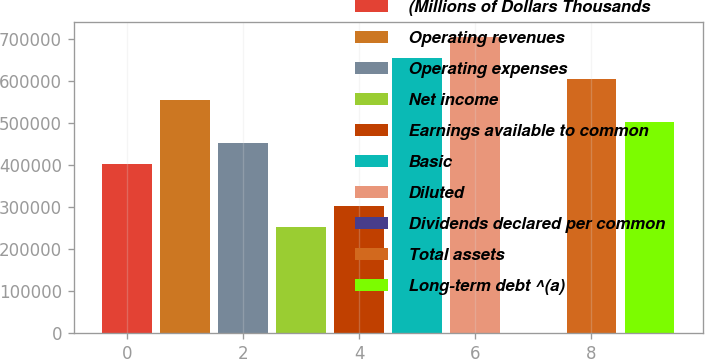<chart> <loc_0><loc_0><loc_500><loc_500><bar_chart><fcel>(Millions of Dollars Thousands<fcel>Operating revenues<fcel>Operating expenses<fcel>Net income<fcel>Earnings available to common<fcel>Basic<fcel>Diluted<fcel>Dividends declared per common<fcel>Total assets<fcel>Long-term debt ^(a)<nl><fcel>403294<fcel>554529<fcel>453705<fcel>252059<fcel>302471<fcel>655352<fcel>705763<fcel>1.2<fcel>604940<fcel>504117<nl></chart> 